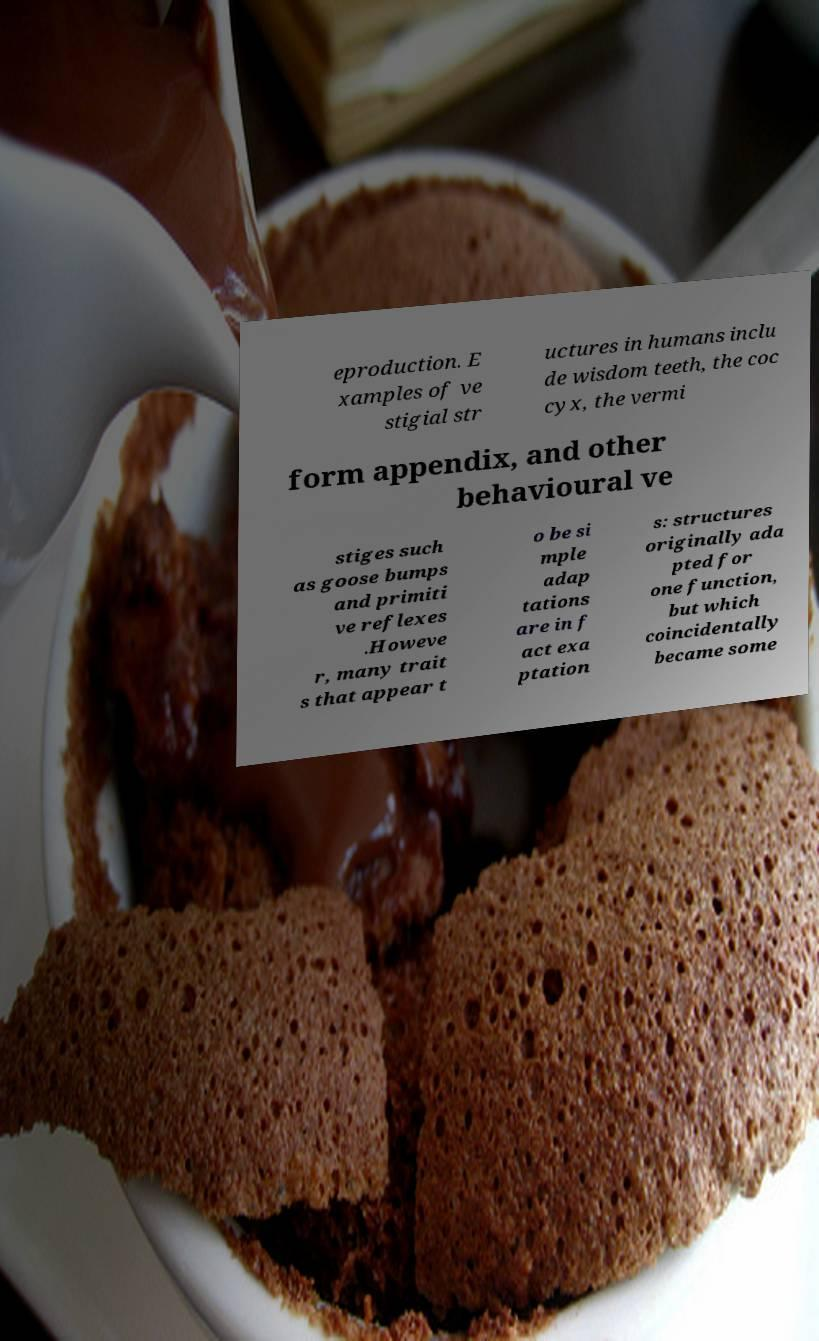What messages or text are displayed in this image? I need them in a readable, typed format. eproduction. E xamples of ve stigial str uctures in humans inclu de wisdom teeth, the coc cyx, the vermi form appendix, and other behavioural ve stiges such as goose bumps and primiti ve reflexes .Howeve r, many trait s that appear t o be si mple adap tations are in f act exa ptation s: structures originally ada pted for one function, but which coincidentally became some 